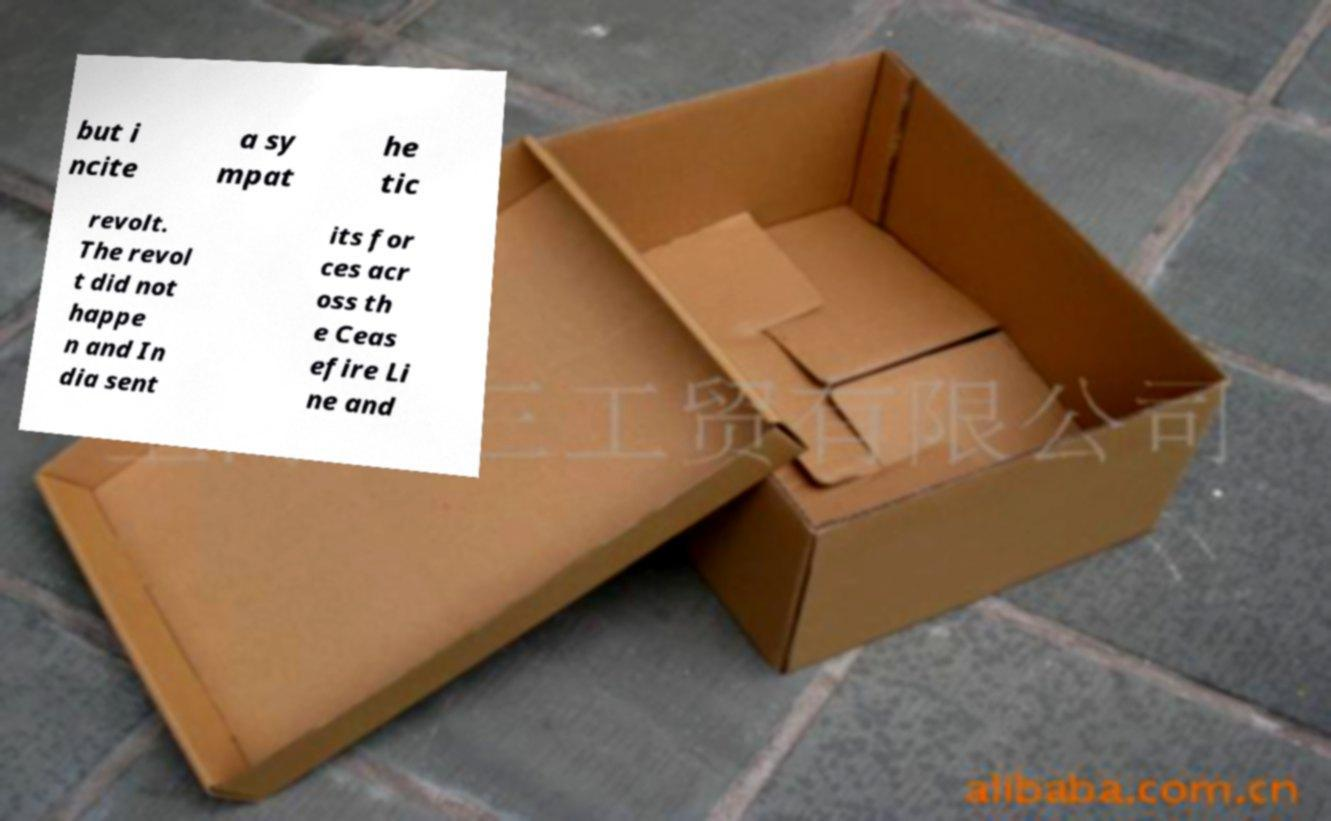Could you assist in decoding the text presented in this image and type it out clearly? but i ncite a sy mpat he tic revolt. The revol t did not happe n and In dia sent its for ces acr oss th e Ceas efire Li ne and 